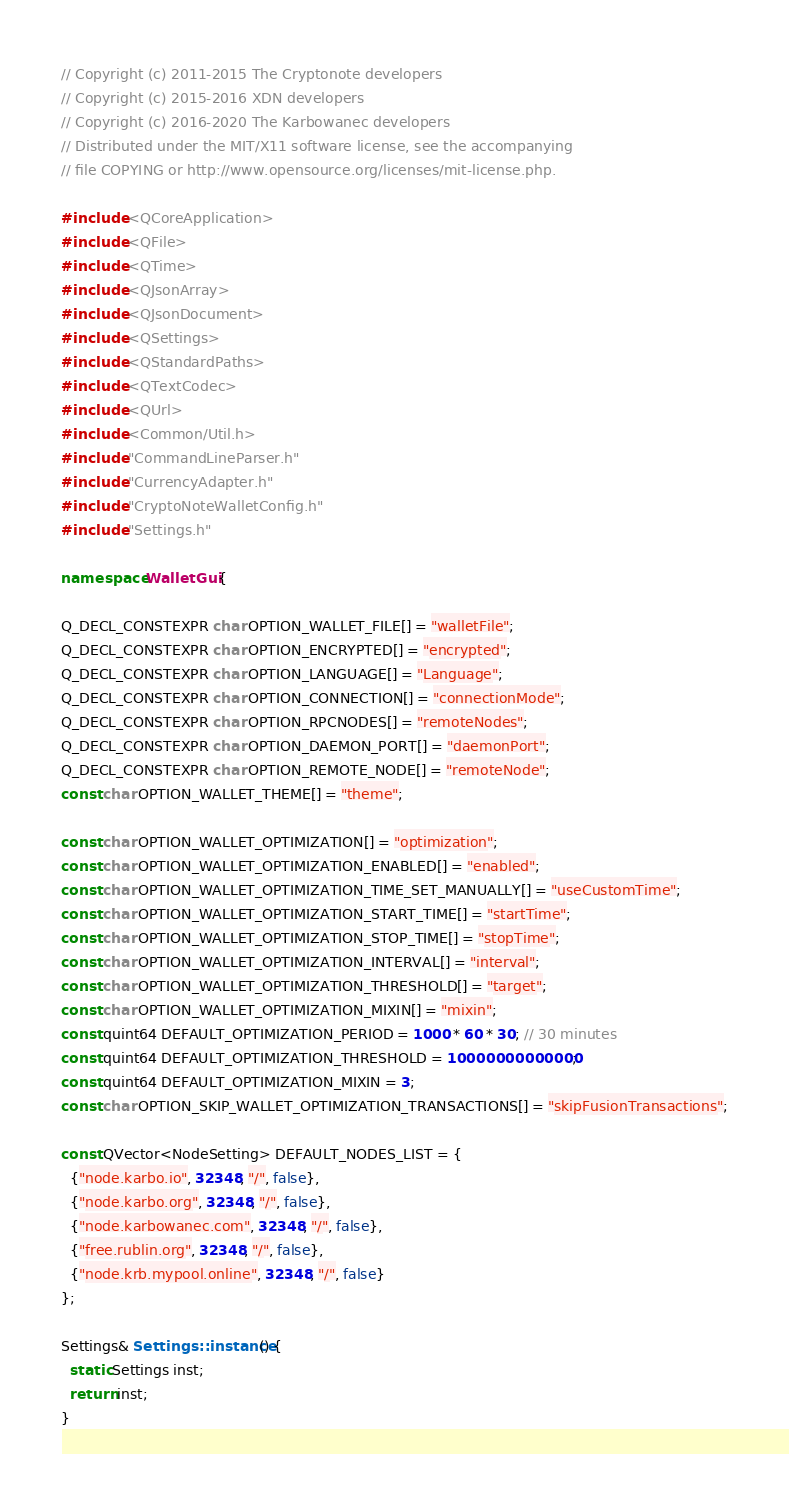<code> <loc_0><loc_0><loc_500><loc_500><_C++_>// Copyright (c) 2011-2015 The Cryptonote developers
// Copyright (c) 2015-2016 XDN developers
// Copyright (c) 2016-2020 The Karbowanec developers
// Distributed under the MIT/X11 software license, see the accompanying
// file COPYING or http://www.opensource.org/licenses/mit-license.php.

#include <QCoreApplication>
#include <QFile>
#include <QTime>
#include <QJsonArray>
#include <QJsonDocument>
#include <QSettings>
#include <QStandardPaths>
#include <QTextCodec>
#include <QUrl>
#include <Common/Util.h>
#include "CommandLineParser.h"
#include "CurrencyAdapter.h"
#include "CryptoNoteWalletConfig.h"
#include "Settings.h"

namespace WalletGui {

Q_DECL_CONSTEXPR char OPTION_WALLET_FILE[] = "walletFile";
Q_DECL_CONSTEXPR char OPTION_ENCRYPTED[] = "encrypted";
Q_DECL_CONSTEXPR char OPTION_LANGUAGE[] = "Language";
Q_DECL_CONSTEXPR char OPTION_CONNECTION[] = "connectionMode";
Q_DECL_CONSTEXPR char OPTION_RPCNODES[] = "remoteNodes";
Q_DECL_CONSTEXPR char OPTION_DAEMON_PORT[] = "daemonPort";
Q_DECL_CONSTEXPR char OPTION_REMOTE_NODE[] = "remoteNode";
const char OPTION_WALLET_THEME[] = "theme";

const char OPTION_WALLET_OPTIMIZATION[] = "optimization";
const char OPTION_WALLET_OPTIMIZATION_ENABLED[] = "enabled";
const char OPTION_WALLET_OPTIMIZATION_TIME_SET_MANUALLY[] = "useCustomTime";
const char OPTION_WALLET_OPTIMIZATION_START_TIME[] = "startTime";
const char OPTION_WALLET_OPTIMIZATION_STOP_TIME[] = "stopTime";
const char OPTION_WALLET_OPTIMIZATION_INTERVAL[] = "interval";
const char OPTION_WALLET_OPTIMIZATION_THRESHOLD[] = "target";
const char OPTION_WALLET_OPTIMIZATION_MIXIN[] = "mixin";
const quint64 DEFAULT_OPTIMIZATION_PERIOD = 1000 * 60 * 30; // 30 minutes
const quint64 DEFAULT_OPTIMIZATION_THRESHOLD = 10000000000000;
const quint64 DEFAULT_OPTIMIZATION_MIXIN = 3;
const char OPTION_SKIP_WALLET_OPTIMIZATION_TRANSACTIONS[] = "skipFusionTransactions";

const QVector<NodeSetting> DEFAULT_NODES_LIST = {
  {"node.karbo.io", 32348, "/", false},
  {"node.karbo.org", 32348, "/", false},
  {"node.karbowanec.com", 32348, "/", false},
  {"free.rublin.org", 32348, "/", false},
  {"node.krb.mypool.online", 32348, "/", false}
};

Settings& Settings::instance() {
  static Settings inst;
  return inst;
}
</code> 